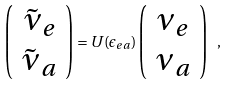<formula> <loc_0><loc_0><loc_500><loc_500>\left ( \begin{array} { c } \tilde { \nu } _ { e } \\ \tilde { \nu } _ { a } \end{array} \right ) = U ( \epsilon _ { e a } ) \left ( \begin{array} { c } \nu _ { e } \\ \nu _ { a } \end{array} \right ) \ ,</formula> 